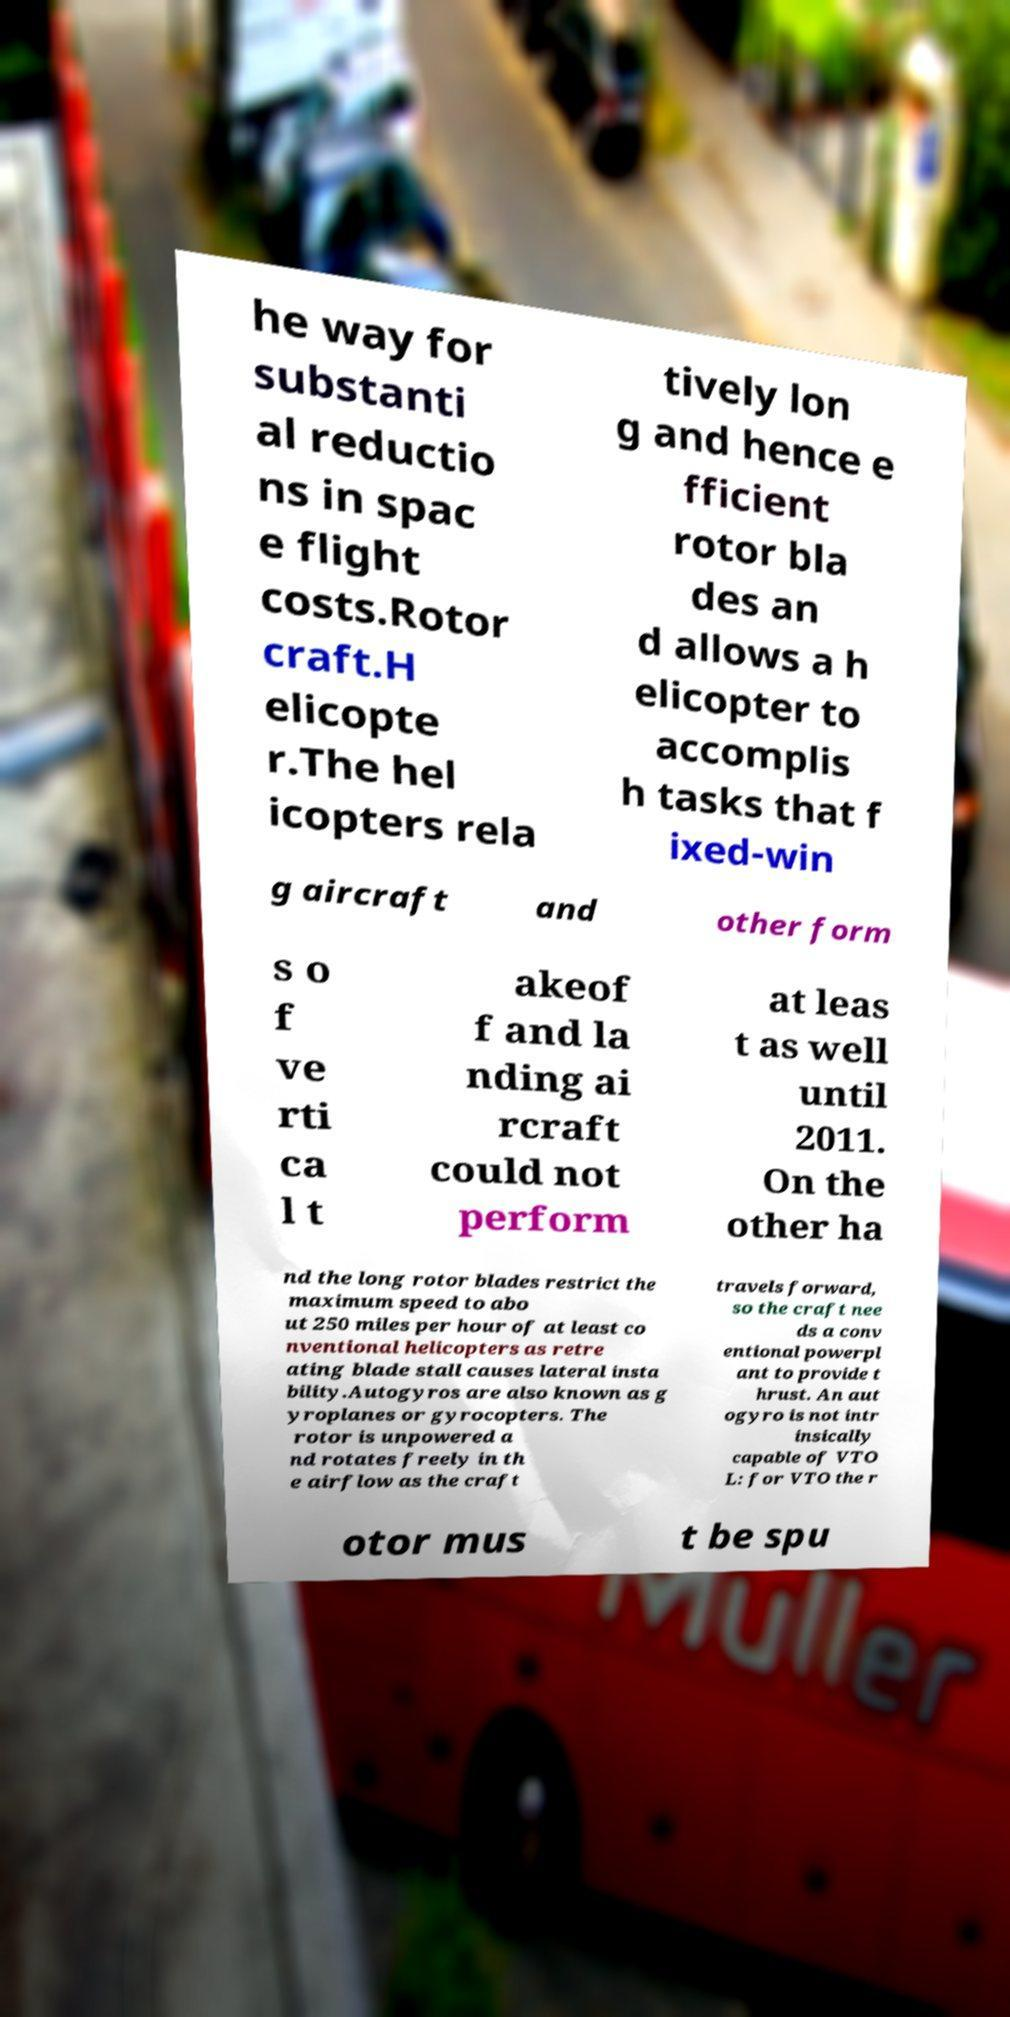Could you assist in decoding the text presented in this image and type it out clearly? he way for substanti al reductio ns in spac e flight costs.Rotor craft.H elicopte r.The hel icopters rela tively lon g and hence e fficient rotor bla des an d allows a h elicopter to accomplis h tasks that f ixed-win g aircraft and other form s o f ve rti ca l t akeof f and la nding ai rcraft could not perform at leas t as well until 2011. On the other ha nd the long rotor blades restrict the maximum speed to abo ut 250 miles per hour of at least co nventional helicopters as retre ating blade stall causes lateral insta bility.Autogyros are also known as g yroplanes or gyrocopters. The rotor is unpowered a nd rotates freely in th e airflow as the craft travels forward, so the craft nee ds a conv entional powerpl ant to provide t hrust. An aut ogyro is not intr insically capable of VTO L: for VTO the r otor mus t be spu 